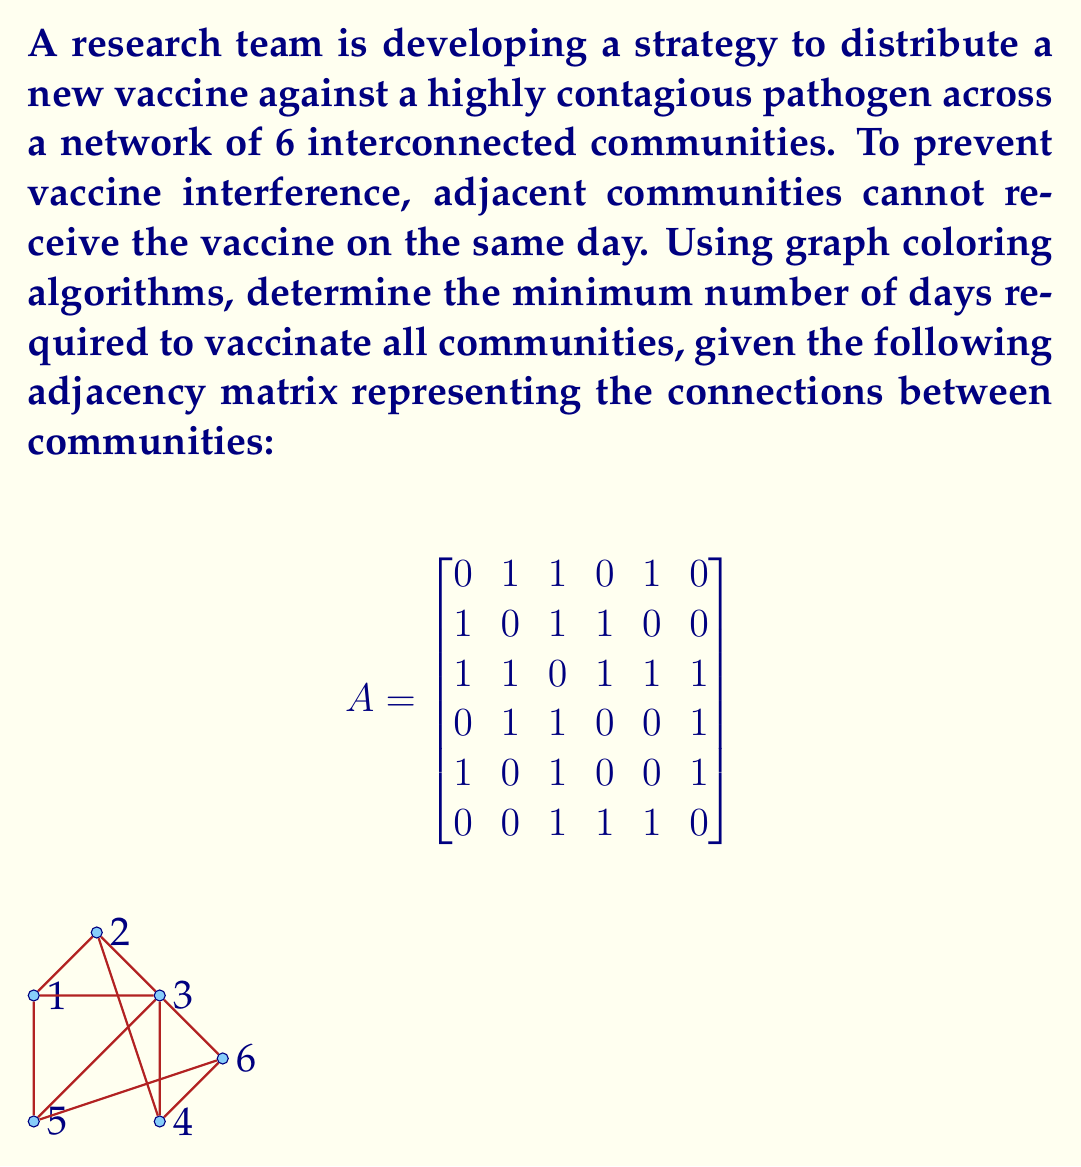Solve this math problem. To solve this problem, we'll use graph coloring algorithms, where each color represents a different vaccination day. The minimum number of colors needed to color the graph such that no adjacent vertices have the same color is equivalent to the minimum number of days required for vaccination.

Step 1: Analyze the graph structure
From the adjacency matrix and the graph visualization, we can see that:
- Community 3 is connected to all other communities.
- Communities 1, 2, 4, 5, and 6 have varying degrees of connectivity.

Step 2: Apply a greedy coloring algorithm
We'll use a simple greedy algorithm to color the graph:
1. Start with community 3 (highest degree) and assign it color 1.
2. For each remaining community, assign the lowest-numbered color that hasn't been used by its adjacent communities.

Coloring process:
- Community 3: Color 1
- Community 1: Color 2 (adjacent to 3)
- Community 2: Color 3 (adjacent to 1 and 3)
- Community 4: Color 2 (adjacent to 2 and 3)
- Community 5: Color 3 (adjacent to 1 and 3)
- Community 6: Color 2 (adjacent to 3, 4, and 5)

Step 3: Verify the coloring
Check that no adjacent communities have the same color:
- Color 1: Community 3
- Color 2: Communities 1, 4, 6
- Color 3: Communities 2, 5

The coloring is valid, and we've used 3 colors.

Step 4: Prove optimality
To prove that 3 is the minimum number of colors needed, we can observe that communities 1, 2, and 3 form a triangle in the graph. A triangle requires at least 3 colors, as each vertex must have a different color from the other two.

Therefore, the minimum number of colors (and thus, the minimum number of days) required to vaccinate all communities is 3.
Answer: 3 days 